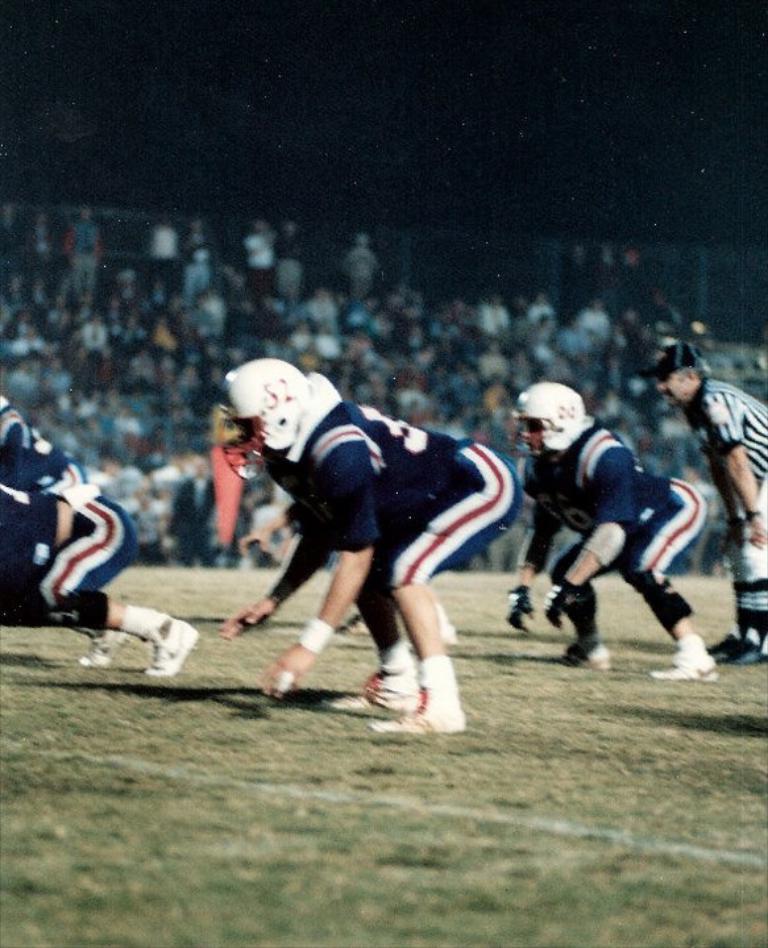Can you describe this image briefly? In this image I can see some people on the ground. I can also see the background is blurred. 